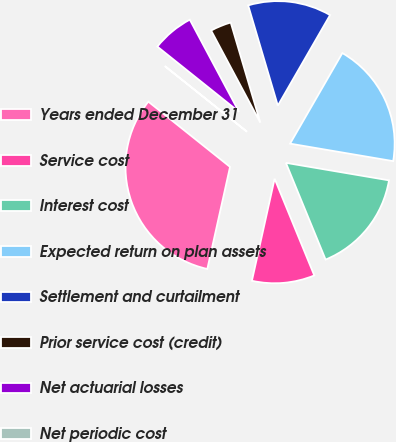Convert chart to OTSL. <chart><loc_0><loc_0><loc_500><loc_500><pie_chart><fcel>Years ended December 31<fcel>Service cost<fcel>Interest cost<fcel>Expected return on plan assets<fcel>Settlement and curtailment<fcel>Prior service cost (credit)<fcel>Net actuarial losses<fcel>Net periodic cost<nl><fcel>32.24%<fcel>9.68%<fcel>16.13%<fcel>19.35%<fcel>12.9%<fcel>3.23%<fcel>6.46%<fcel>0.01%<nl></chart> 